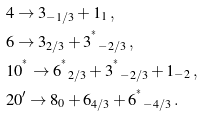<formula> <loc_0><loc_0><loc_500><loc_500>& { 4 } \to { 3 } _ { - 1 / 3 } + { 1 } _ { 1 } \, , \\ & { 6 } \to { 3 } _ { 2 / 3 } + { 3 ^ { ^ { * } } } _ { - 2 / 3 } \, , \\ & { 1 0 ^ { ^ { * } } } \to { 6 ^ { ^ { * } } } _ { 2 / 3 } + { 3 ^ { ^ { * } } } _ { - 2 / 3 } + { 1 } _ { - 2 } \, , \\ & { 2 0 ^ { \prime } } \to { 8 } _ { 0 } + { 6 } _ { 4 / 3 } + { 6 ^ { ^ { * } } } _ { - 4 / 3 } \, .</formula> 